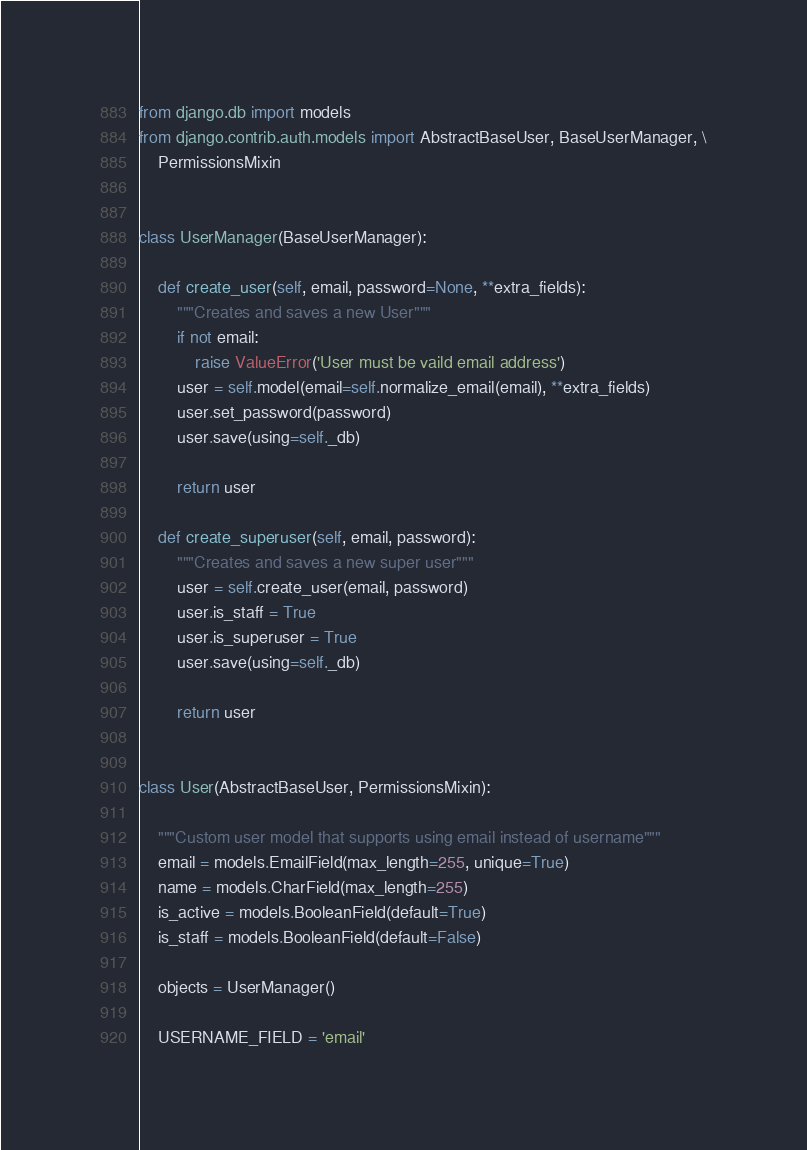Convert code to text. <code><loc_0><loc_0><loc_500><loc_500><_Python_>from django.db import models
from django.contrib.auth.models import AbstractBaseUser, BaseUserManager, \
    PermissionsMixin


class UserManager(BaseUserManager):

    def create_user(self, email, password=None, **extra_fields):
        """Creates and saves a new User"""
        if not email:
            raise ValueError('User must be vaild email address')
        user = self.model(email=self.normalize_email(email), **extra_fields)
        user.set_password(password)
        user.save(using=self._db)

        return user
    
    def create_superuser(self, email, password):
        """Creates and saves a new super user"""
        user = self.create_user(email, password)
        user.is_staff = True
        user.is_superuser = True
        user.save(using=self._db)

        return user


class User(AbstractBaseUser, PermissionsMixin):

    """Custom user model that supports using email instead of username"""
    email = models.EmailField(max_length=255, unique=True)
    name = models.CharField(max_length=255)
    is_active = models.BooleanField(default=True)
    is_staff = models.BooleanField(default=False)

    objects = UserManager()

    USERNAME_FIELD = 'email'
</code> 